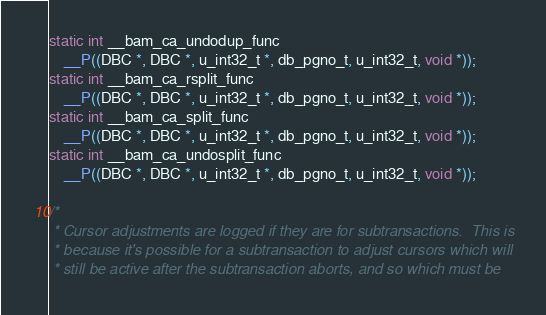<code> <loc_0><loc_0><loc_500><loc_500><_C_>static int __bam_ca_undodup_func
    __P((DBC *, DBC *, u_int32_t *, db_pgno_t, u_int32_t, void *));
static int __bam_ca_rsplit_func
    __P((DBC *, DBC *, u_int32_t *, db_pgno_t, u_int32_t, void *));
static int __bam_ca_split_func
    __P((DBC *, DBC *, u_int32_t *, db_pgno_t, u_int32_t, void *));
static int __bam_ca_undosplit_func
    __P((DBC *, DBC *, u_int32_t *, db_pgno_t, u_int32_t, void *));

/*
 * Cursor adjustments are logged if they are for subtransactions.  This is
 * because it's possible for a subtransaction to adjust cursors which will
 * still be active after the subtransaction aborts, and so which must be</code> 